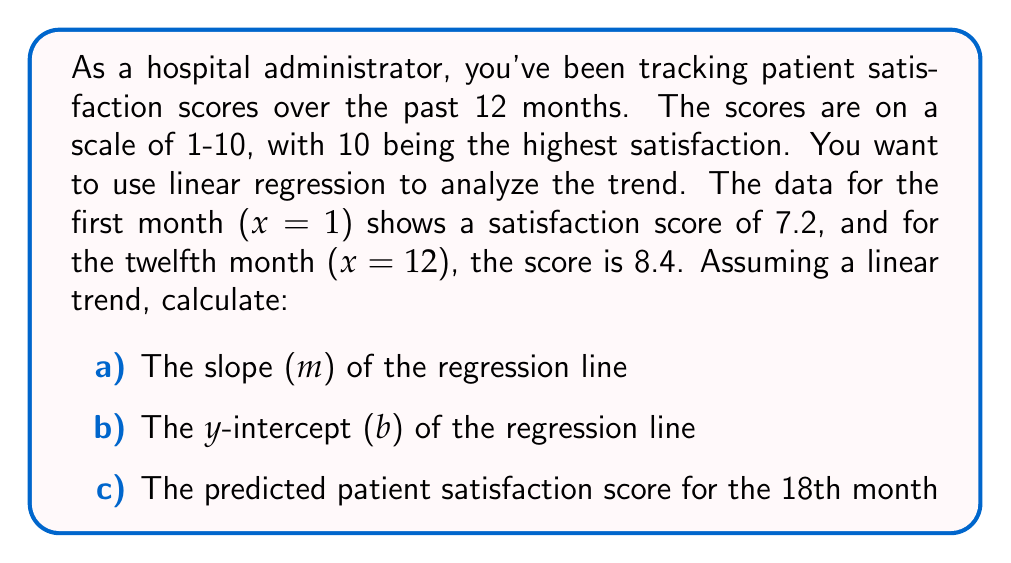Could you help me with this problem? Let's approach this step-by-step using the point-slope form of a linear equation:

1) We have two points: (1, 7.2) and (12, 8.4)

2) Calculate the slope (m):
   $$ m = \frac{y_2 - y_1}{x_2 - x_1} = \frac{8.4 - 7.2}{12 - 1} = \frac{1.2}{11} = 0.1091 $$

3) Use the point-slope form with (1, 7.2):
   $$ y - 7.2 = 0.1091(x - 1) $$

4) Simplify to get y-intercept (b):
   $$ y = 0.1091x - 0.1091 + 7.2 $$
   $$ y = 0.1091x + 7.0909 $$

   So, b = 7.0909

5) To predict the score for the 18th month, substitute x = 18:
   $$ y = 0.1091(18) + 7.0909 $$
   $$ y = 1.9638 + 7.0909 = 9.0547 $$
Answer: a) Slope (m) = 0.1091
b) Y-intercept (b) = 7.0909
c) Predicted satisfaction score for 18th month = 9.0547 